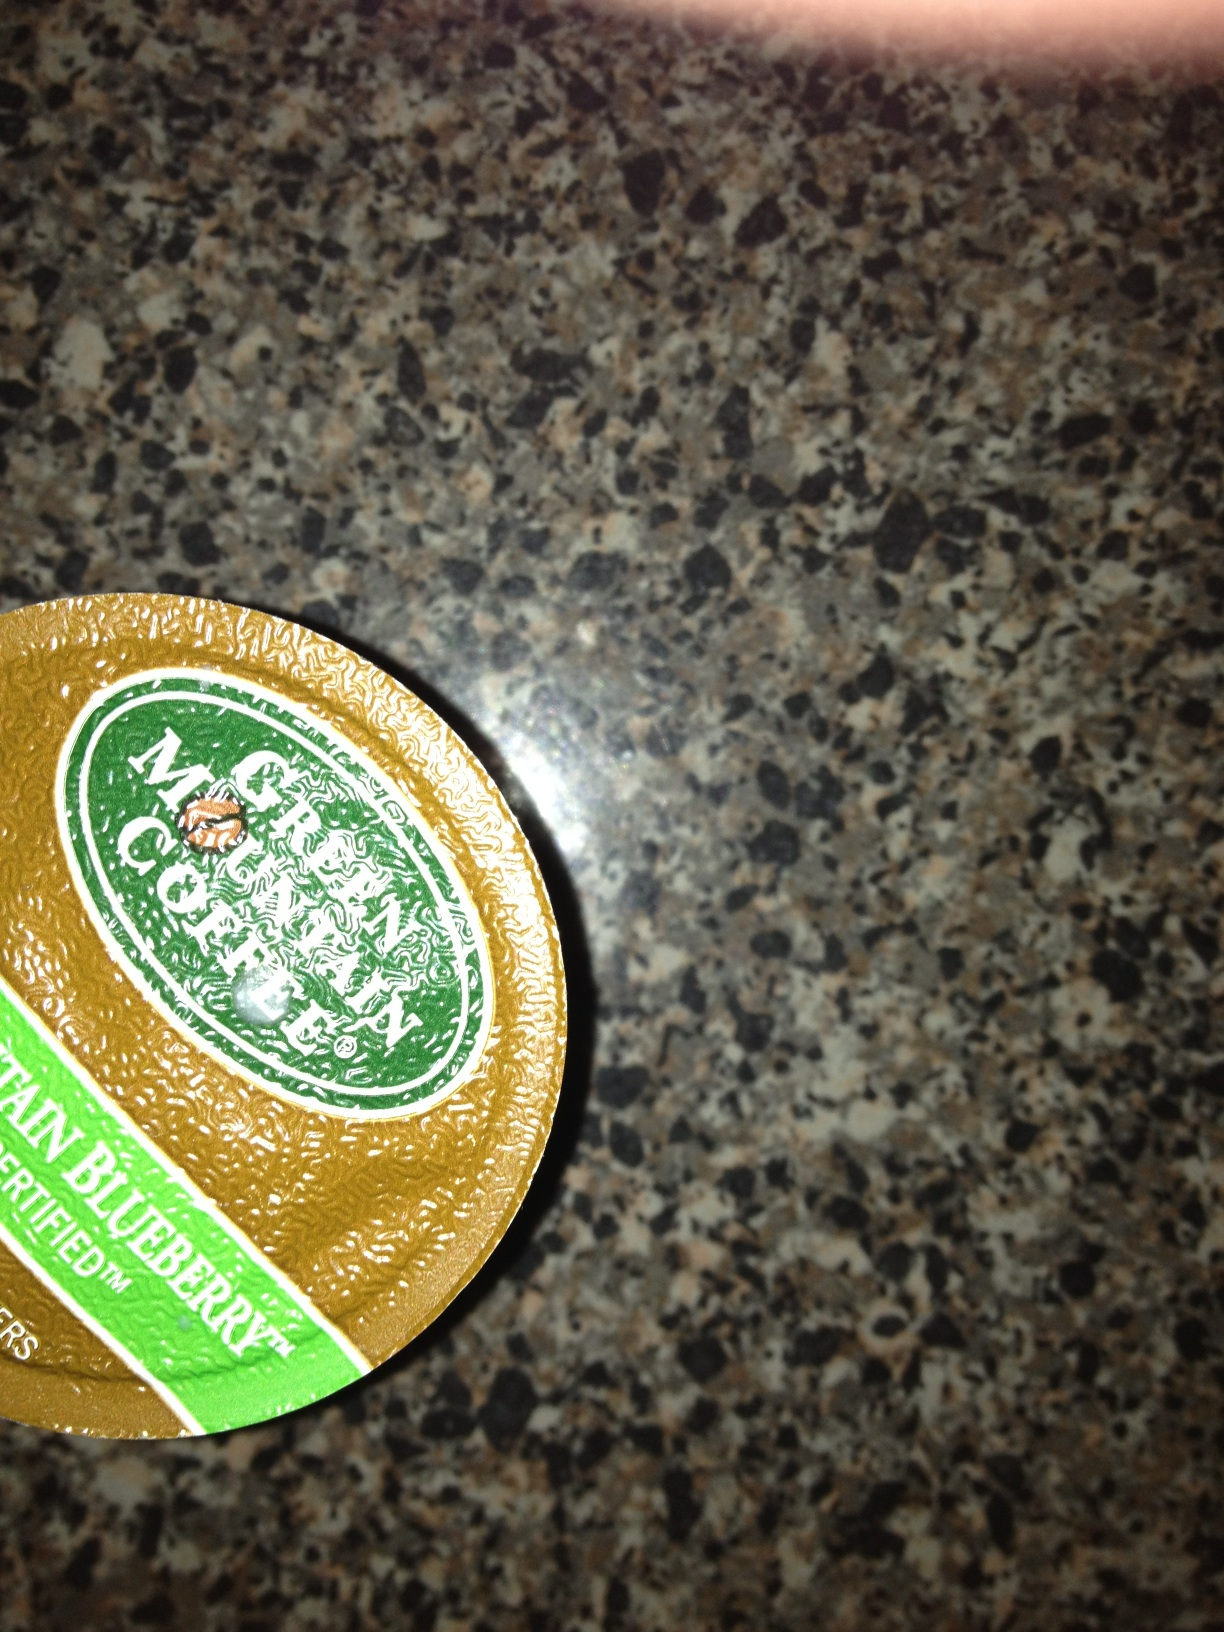Describe a morning scenario where a person enjoys Mountain Blueberry coffee. It's a crisp, early morning as dawn light begins to filter through the kitchen windows. Jane reaches for her trusty Keurig machine and inserts a pod of Green Mountain's Mountain Blueberry coffee. As the hot water presses through the pod, the kitchen fills with the enticing aroma of fresh coffee intermingled with sweet blueberries. She pours herself a cup and steps onto the porch to enjoy the soft morning breeze. Each sip offers a satisfying mix of deep coffee richness and vibrant blueberry notes, perfectly complemented by the serene beauty of the morning. It's the ideal way to start her day, providing a moment of tranquility and delight before the hustle and bustle begins. 